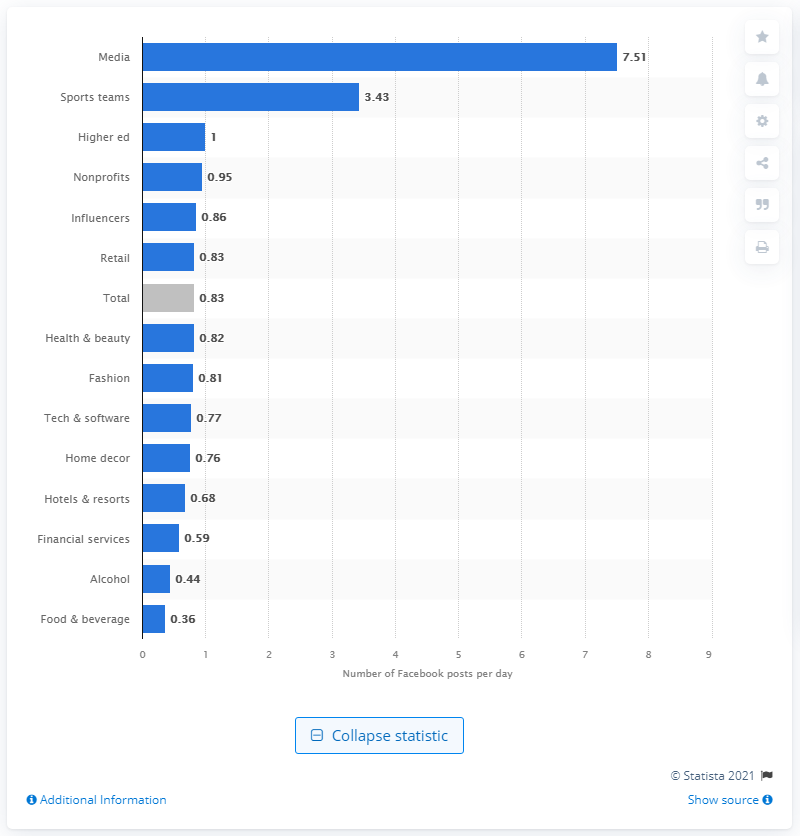Highlight a few significant elements in this photo. On average, fashion brands post 0.81 social media posts to their network every day. The average number of posts per day for media brands on Facebook is 7.51. 